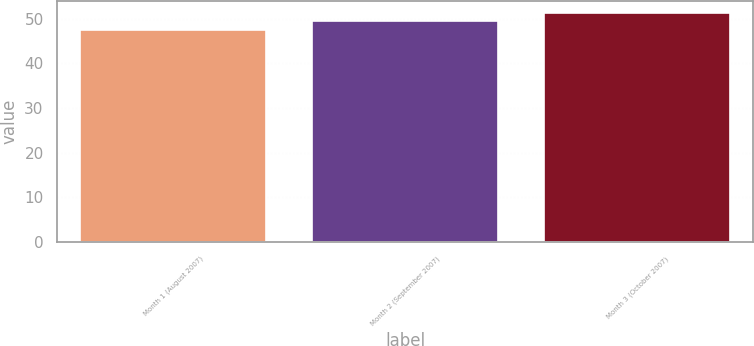Convert chart to OTSL. <chart><loc_0><loc_0><loc_500><loc_500><bar_chart><fcel>Month 1 (August 2007)<fcel>Month 2 (September 2007)<fcel>Month 3 (October 2007)<nl><fcel>47.4<fcel>49.49<fcel>51.39<nl></chart> 